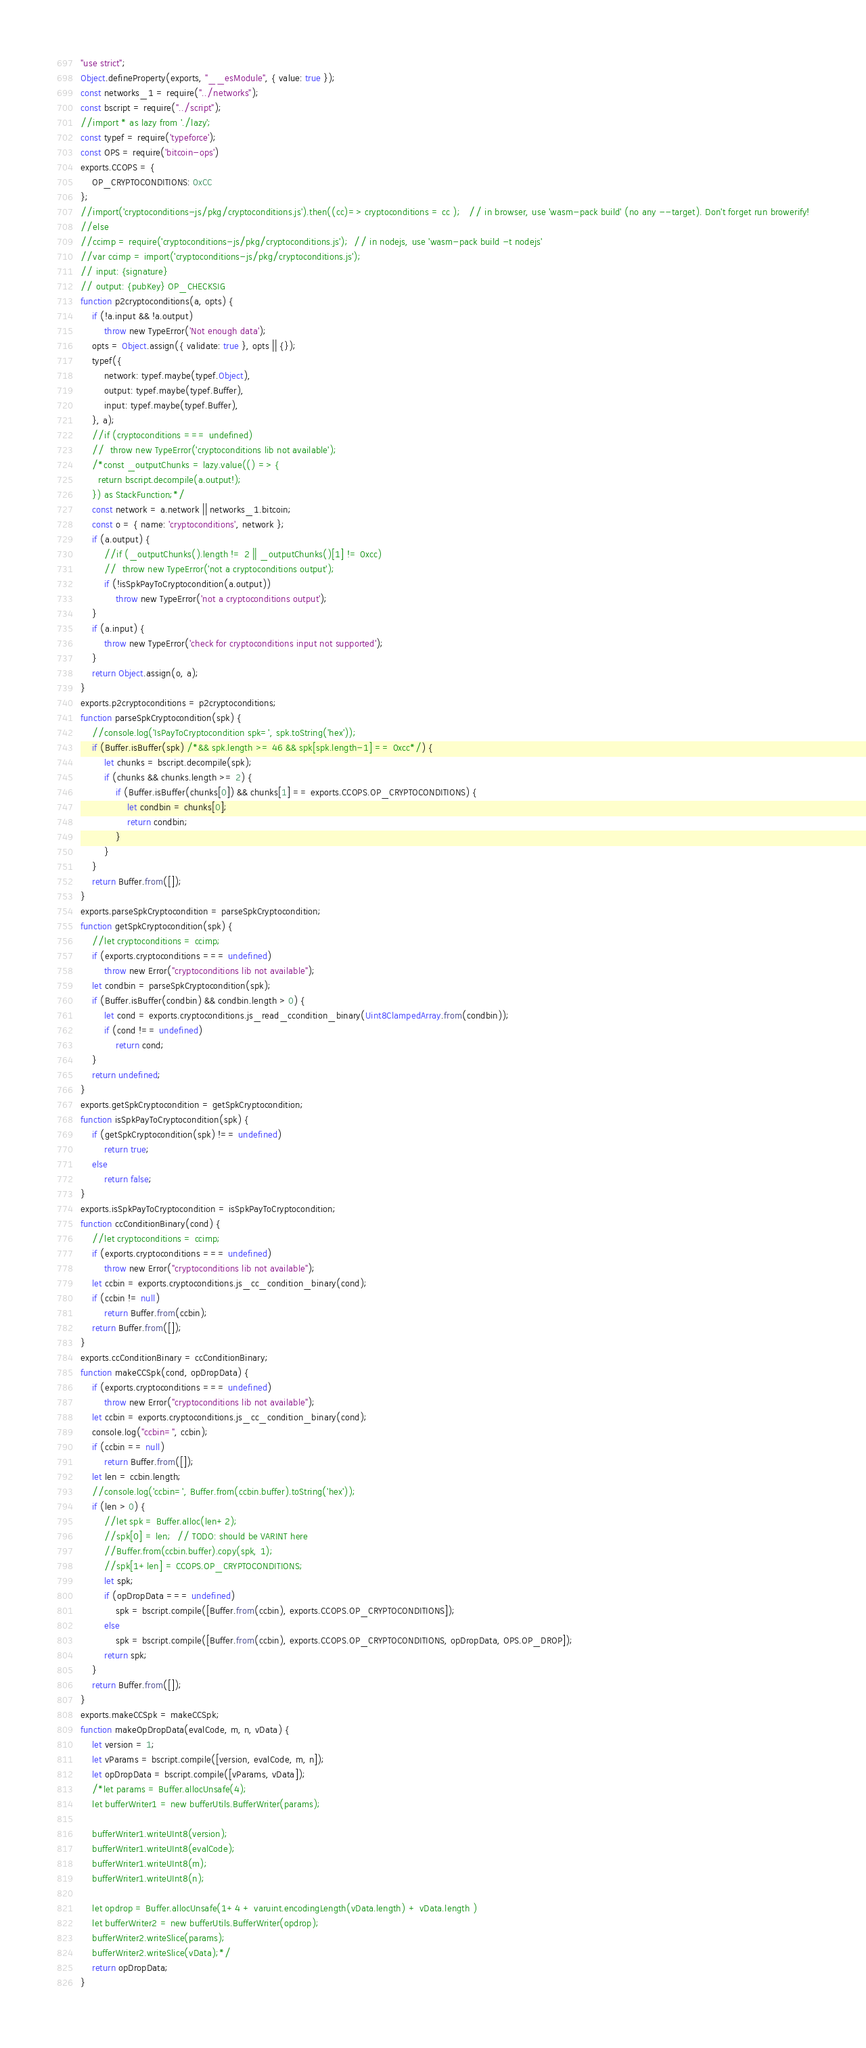<code> <loc_0><loc_0><loc_500><loc_500><_JavaScript_>"use strict";
Object.defineProperty(exports, "__esModule", { value: true });
const networks_1 = require("../networks");
const bscript = require("../script");
//import * as lazy from './lazy';
const typef = require('typeforce');
const OPS = require('bitcoin-ops')
exports.CCOPS = {
    OP_CRYPTOCONDITIONS: 0xCC
};
//import('cryptoconditions-js/pkg/cryptoconditions.js').then((cc)=> cryptoconditions = cc );   // in browser, use 'wasm-pack build' (no any --target). Don't forget run browerify!
//else
//ccimp = require('cryptoconditions-js/pkg/cryptoconditions.js');  // in nodejs, use 'wasm-pack build -t nodejs'
//var ccimp = import('cryptoconditions-js/pkg/cryptoconditions.js'); 
// input: {signature}
// output: {pubKey} OP_CHECKSIG
function p2cryptoconditions(a, opts) {
    if (!a.input && !a.output)
        throw new TypeError('Not enough data');
    opts = Object.assign({ validate: true }, opts || {});
    typef({
        network: typef.maybe(typef.Object),
        output: typef.maybe(typef.Buffer),
        input: typef.maybe(typef.Buffer),
    }, a);
    //if (cryptoconditions === undefined)
    //  throw new TypeError('cryptoconditions lib not available');
    /*const _outputChunks = lazy.value(() => {
      return bscript.decompile(a.output!);
    }) as StackFunction;*/
    const network = a.network || networks_1.bitcoin;
    const o = { name: 'cryptoconditions', network };
    if (a.output) {
        //if (_outputChunks().length != 2 || _outputChunks()[1] != 0xcc)
        //  throw new TypeError('not a cryptoconditions output');
        if (!isSpkPayToCryptocondition(a.output))
            throw new TypeError('not a cryptoconditions output');
    }
    if (a.input) {
        throw new TypeError('check for cryptoconditions input not supported');
    }
    return Object.assign(o, a);
}
exports.p2cryptoconditions = p2cryptoconditions;
function parseSpkCryptocondition(spk) {
    //console.log('IsPayToCryptocondition spk=', spk.toString('hex'));
    if (Buffer.isBuffer(spk) /*&& spk.length >= 46 && spk[spk.length-1] == 0xcc*/) {
        let chunks = bscript.decompile(spk);
        if (chunks && chunks.length >= 2) {
            if (Buffer.isBuffer(chunks[0]) && chunks[1] == exports.CCOPS.OP_CRYPTOCONDITIONS) {
                let condbin = chunks[0];
                return condbin;
            }
        }
    }
    return Buffer.from([]);
}
exports.parseSpkCryptocondition = parseSpkCryptocondition;
function getSpkCryptocondition(spk) {
    //let cryptoconditions = ccimp;
    if (exports.cryptoconditions === undefined)
        throw new Error("cryptoconditions lib not available");
    let condbin = parseSpkCryptocondition(spk);
    if (Buffer.isBuffer(condbin) && condbin.length > 0) {
        let cond = exports.cryptoconditions.js_read_ccondition_binary(Uint8ClampedArray.from(condbin));
        if (cond !== undefined)
            return cond;
    }
    return undefined;
}
exports.getSpkCryptocondition = getSpkCryptocondition;
function isSpkPayToCryptocondition(spk) {
    if (getSpkCryptocondition(spk) !== undefined)
        return true;
    else
        return false;
}
exports.isSpkPayToCryptocondition = isSpkPayToCryptocondition;
function ccConditionBinary(cond) {
    //let cryptoconditions = ccimp;
    if (exports.cryptoconditions === undefined)
        throw new Error("cryptoconditions lib not available");
    let ccbin = exports.cryptoconditions.js_cc_condition_binary(cond);
    if (ccbin != null)
        return Buffer.from(ccbin);
    return Buffer.from([]);
}
exports.ccConditionBinary = ccConditionBinary;
function makeCCSpk(cond, opDropData) {
    if (exports.cryptoconditions === undefined)
        throw new Error("cryptoconditions lib not available");
    let ccbin = exports.cryptoconditions.js_cc_condition_binary(cond);
    console.log("ccbin=", ccbin);
    if (ccbin == null)
        return Buffer.from([]);
    let len = ccbin.length;
    //console.log('ccbin=', Buffer.from(ccbin.buffer).toString('hex'));
    if (len > 0) {
        //let spk = Buffer.alloc(len+2);
        //spk[0] = len;  // TODO: should be VARINT here
        //Buffer.from(ccbin.buffer).copy(spk, 1);
        //spk[1+len] = CCOPS.OP_CRYPTOCONDITIONS;
        let spk;
        if (opDropData === undefined)
            spk = bscript.compile([Buffer.from(ccbin), exports.CCOPS.OP_CRYPTOCONDITIONS]);
        else
            spk = bscript.compile([Buffer.from(ccbin), exports.CCOPS.OP_CRYPTOCONDITIONS, opDropData, OPS.OP_DROP]);
        return spk;
    }
    return Buffer.from([]);
}
exports.makeCCSpk = makeCCSpk;
function makeOpDropData(evalCode, m, n, vData) {
    let version = 1;
    let vParams = bscript.compile([version, evalCode, m, n]);
    let opDropData = bscript.compile([vParams, vData]);
    /*let params = Buffer.allocUnsafe(4);
    let bufferWriter1 = new bufferUtils.BufferWriter(params);
  
    bufferWriter1.writeUInt8(version);
    bufferWriter1.writeUInt8(evalCode);
    bufferWriter1.writeUInt8(m);
    bufferWriter1.writeUInt8(n);
  
    let opdrop = Buffer.allocUnsafe(1+4 + varuint.encodingLength(vData.length) + vData.length )
    let bufferWriter2 = new bufferUtils.BufferWriter(opdrop);
    bufferWriter2.writeSlice(params);
    bufferWriter2.writeSlice(vData);*/
    return opDropData;
}</code> 